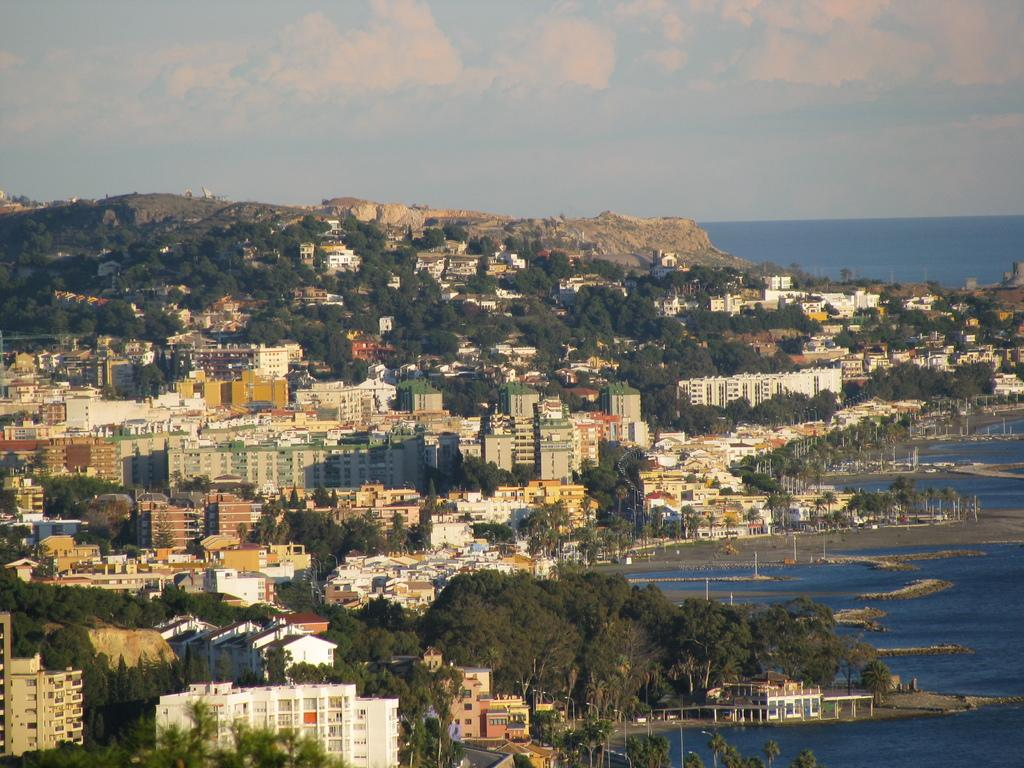What type of structures can be seen in the image? There are buildings in the image. What architectural features can be observed on the buildings? There are windows visible on the buildings. What type of vegetation is present in the image? There are trees in the image. What type of street furniture can be seen in the image? There are light-poles in the image. What type of natural landmark is visible in the image? There are mountains in the image. What type of body of water is present in the image? There is water in the image. What is the color of the sky in the image? The sky is blue and white in color. What type of organization is performing on the stage in the image? There is no stage present in the image, so it is not possible to answer that question. 